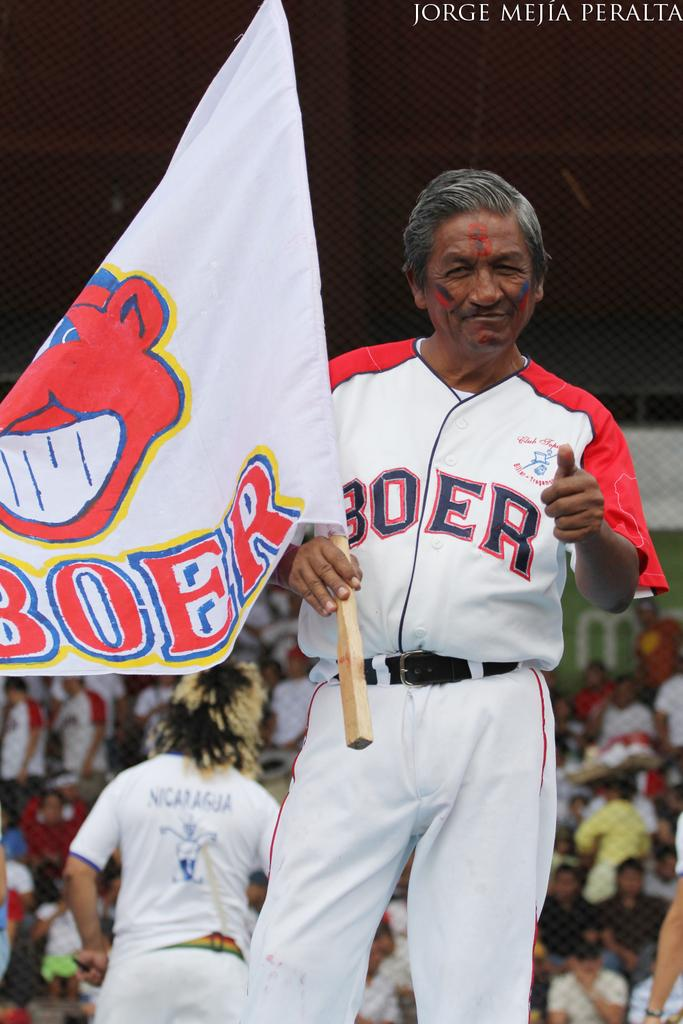<image>
Present a compact description of the photo's key features. A man in a baseball uniform has a flag that says Boer on it. 